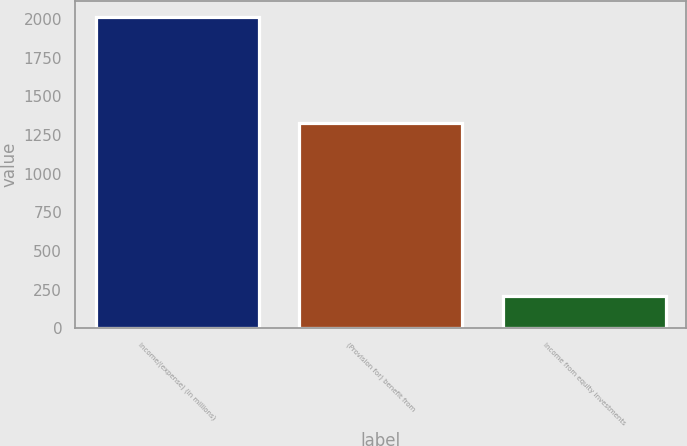<chart> <loc_0><loc_0><loc_500><loc_500><bar_chart><fcel>Income/(expense) (in millions)<fcel>(Provision for) benefit from<fcel>Income from equity investments<nl><fcel>2015<fcel>1330<fcel>208<nl></chart> 